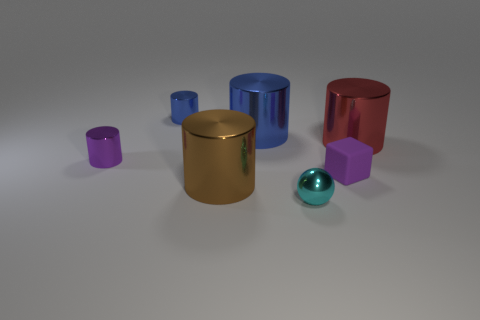Is the big red shiny object the same shape as the big brown object?
Give a very brief answer. Yes. Is there a small cyan ball that has the same material as the large red cylinder?
Provide a short and direct response. Yes. There is a tiny object that is left of the brown thing and in front of the big red cylinder; what color is it?
Your answer should be very brief. Purple. There is a small purple thing that is to the right of the small blue metallic object; what is its material?
Your response must be concise. Rubber. Is there another thing that has the same shape as the brown thing?
Give a very brief answer. Yes. How many other things are there of the same shape as the cyan metallic object?
Offer a very short reply. 0. There is a big red metal thing; does it have the same shape as the small purple thing on the left side of the cyan metal object?
Provide a short and direct response. Yes. Are there any other things that have the same material as the cube?
Make the answer very short. No. There is a brown thing that is the same shape as the small blue object; what is it made of?
Provide a succinct answer. Metal. What number of tiny things are cyan metallic objects or purple matte things?
Keep it short and to the point. 2. 